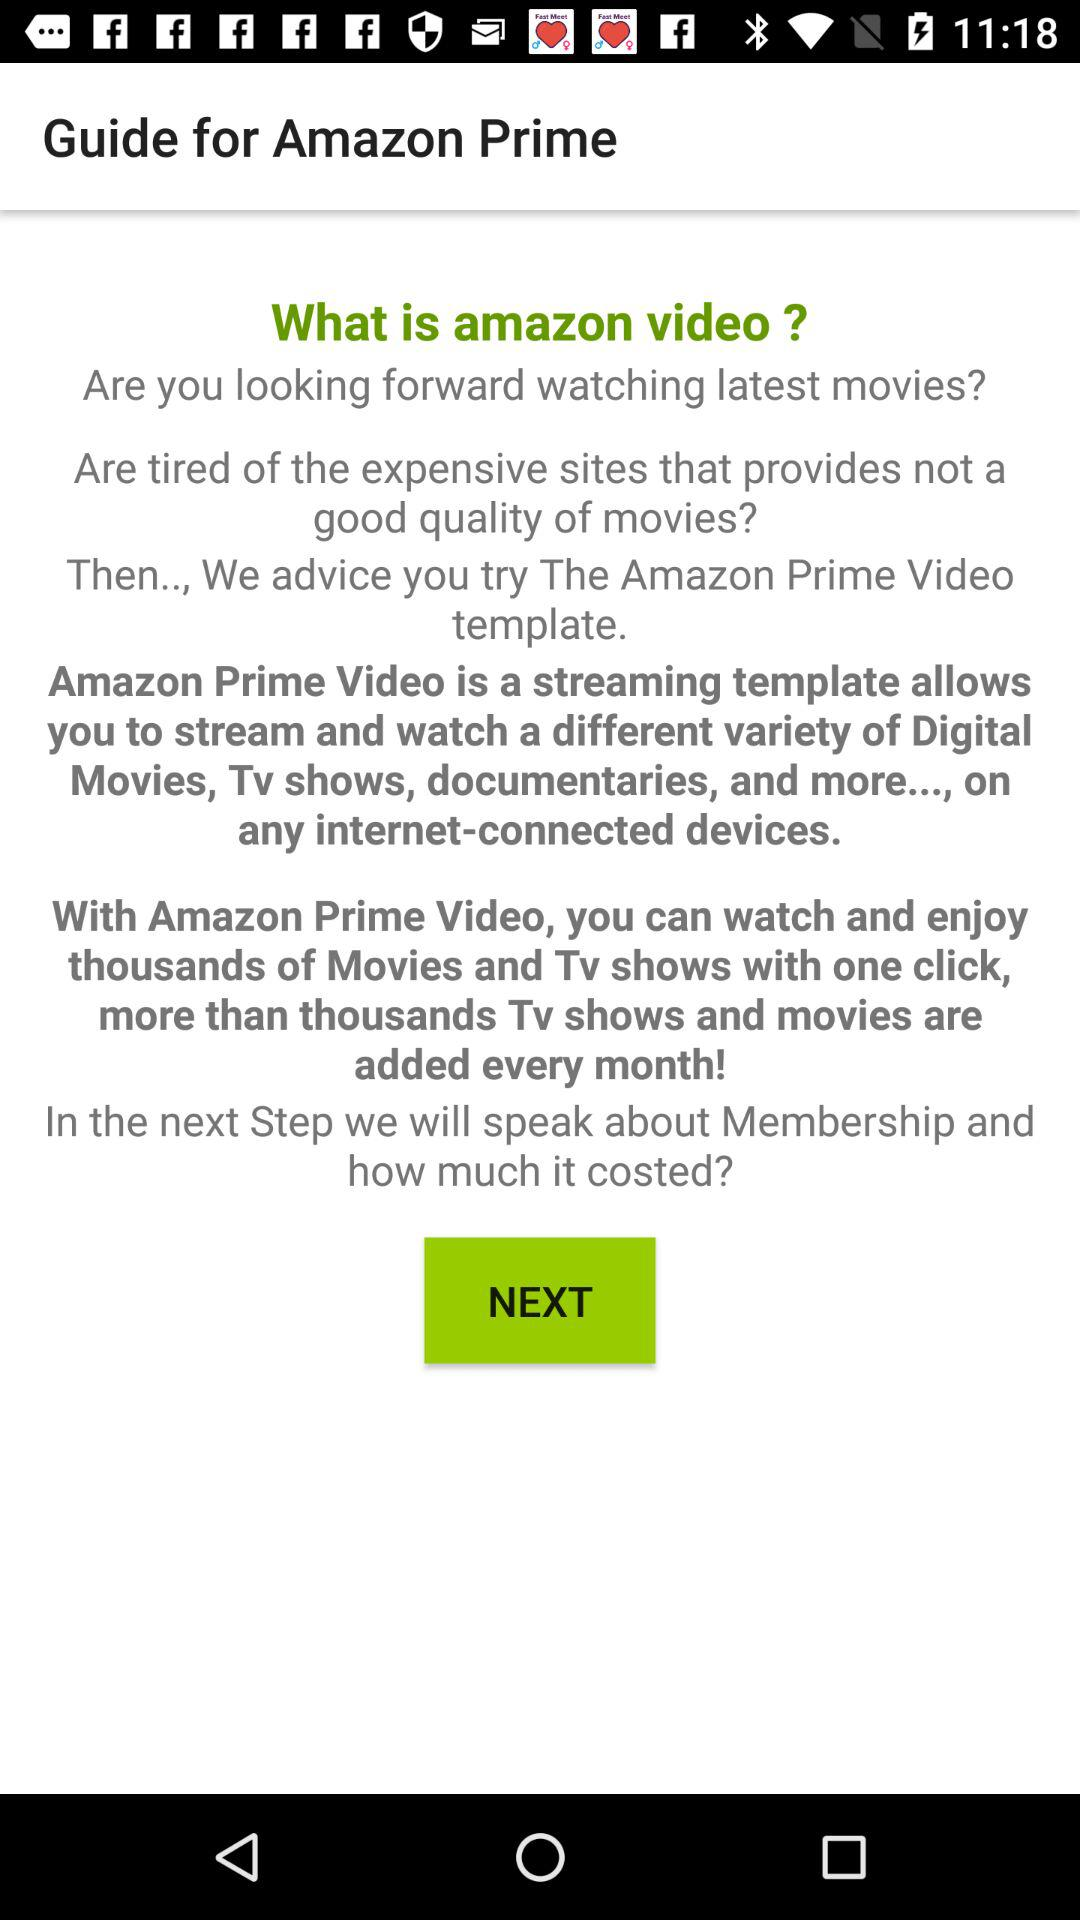How many videos are available in "amazon video"?
When the provided information is insufficient, respond with <no answer>. <no answer> 